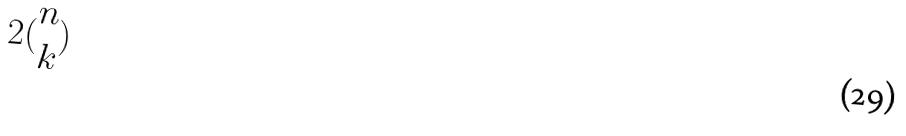<formula> <loc_0><loc_0><loc_500><loc_500>2 ( \begin{matrix} n \\ k \end{matrix} )</formula> 